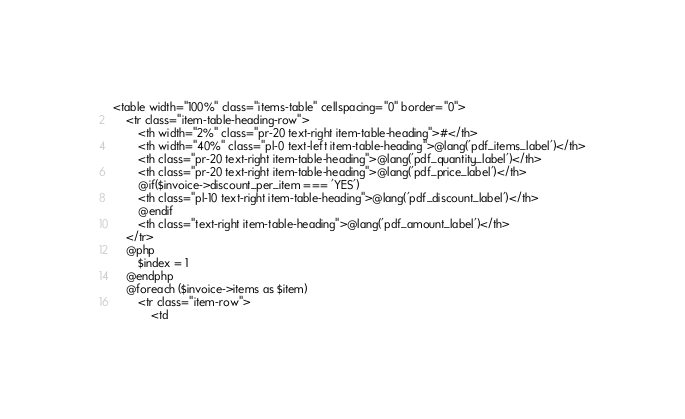Convert code to text. <code><loc_0><loc_0><loc_500><loc_500><_PHP_><table width="100%" class="items-table" cellspacing="0" border="0">
    <tr class="item-table-heading-row">
        <th width="2%" class="pr-20 text-right item-table-heading">#</th>
        <th width="40%" class="pl-0 text-left item-table-heading">@lang('pdf_items_label')</th>
        <th class="pr-20 text-right item-table-heading">@lang('pdf_quantity_label')</th>
        <th class="pr-20 text-right item-table-heading">@lang('pdf_price_label')</th>
        @if($invoice->discount_per_item === 'YES')
        <th class="pl-10 text-right item-table-heading">@lang('pdf_discount_label')</th>
        @endif
        <th class="text-right item-table-heading">@lang('pdf_amount_label')</th>
    </tr>
    @php
        $index = 1
    @endphp
    @foreach ($invoice->items as $item)
        <tr class="item-row">
            <td</code> 